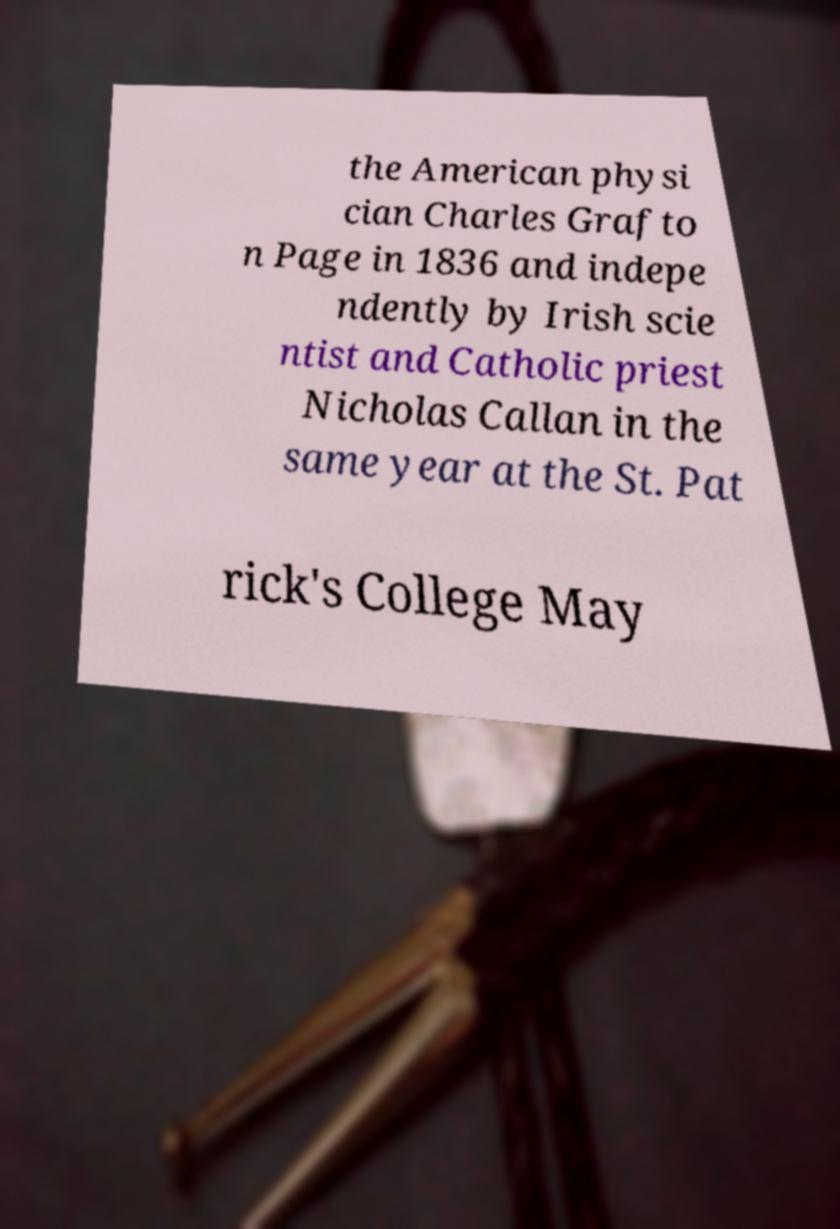Can you accurately transcribe the text from the provided image for me? the American physi cian Charles Grafto n Page in 1836 and indepe ndently by Irish scie ntist and Catholic priest Nicholas Callan in the same year at the St. Pat rick's College May 